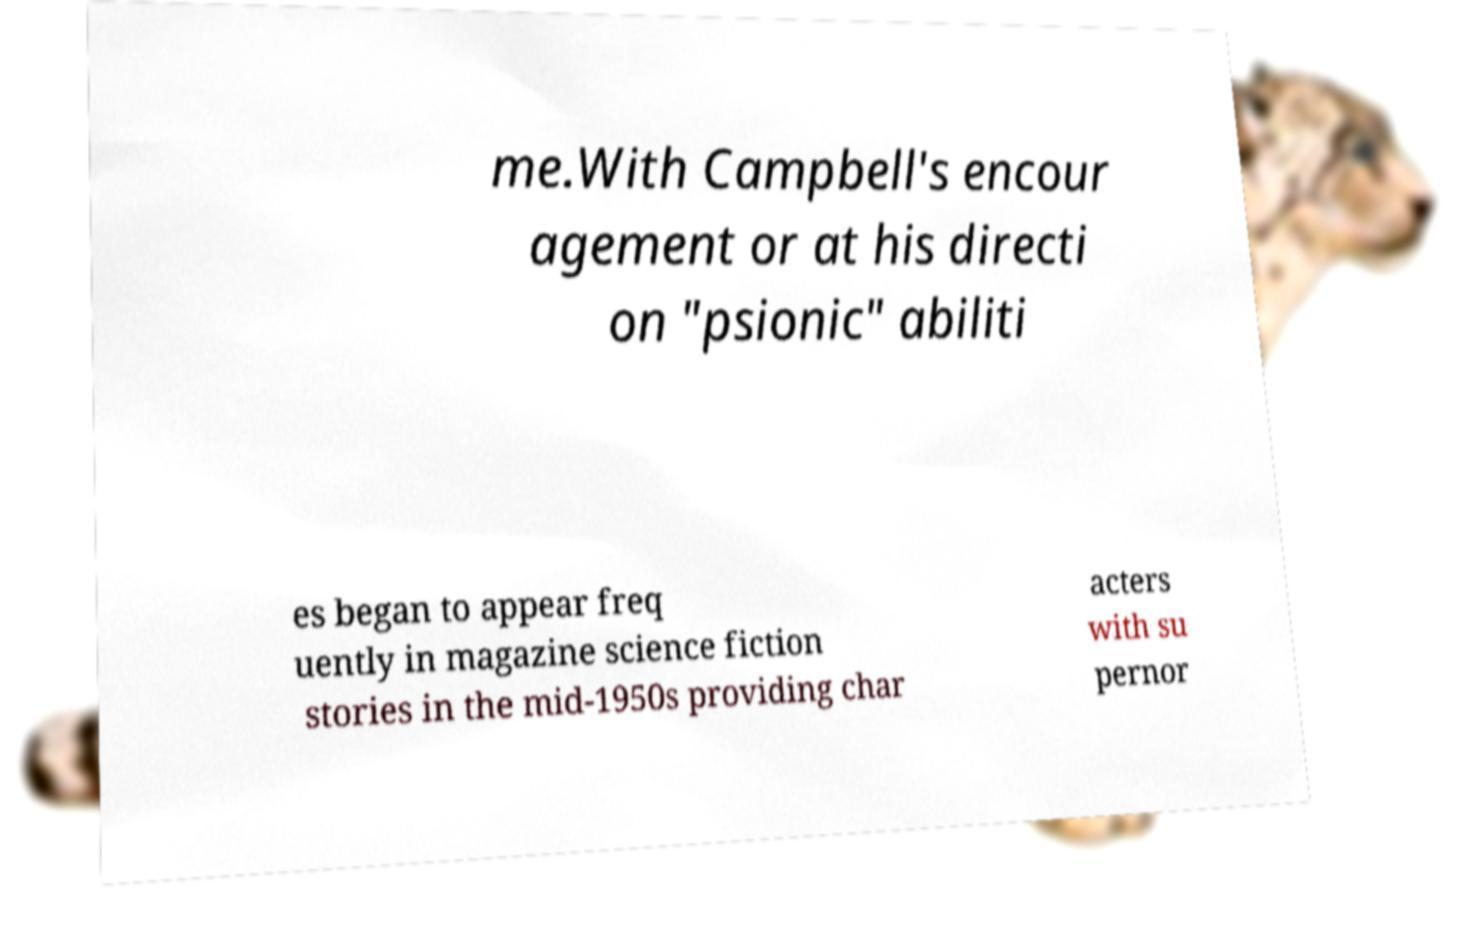Please identify and transcribe the text found in this image. me.With Campbell's encour agement or at his directi on "psionic" abiliti es began to appear freq uently in magazine science fiction stories in the mid-1950s providing char acters with su pernor 